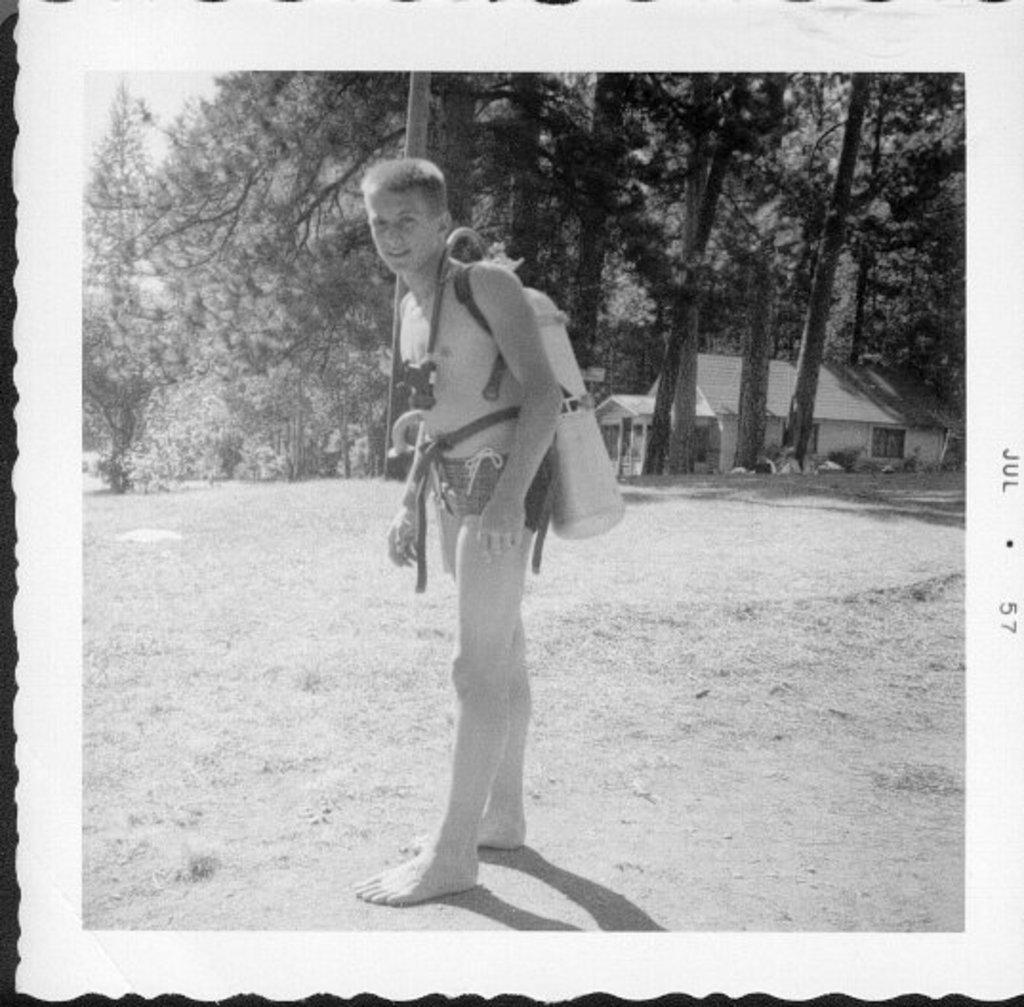What is the color scheme of the image? The image is black and white. What is the main subject of the image? There is a boy standing in the image. What can be seen on the right side of the image? There are houses and trees on the right side of the image. What is the title of the book the boy is reading in the image? There is no book visible in the image, so it is not possible to determine the title. 